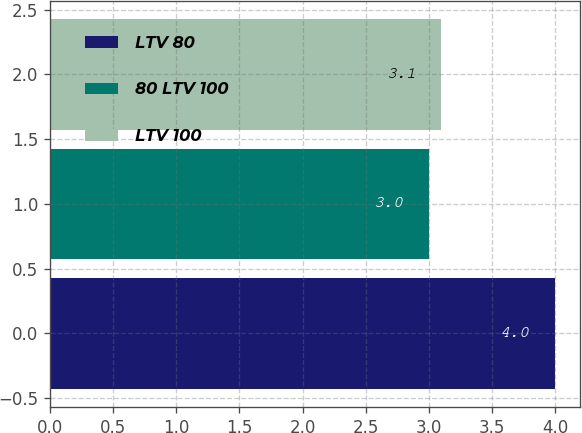<chart> <loc_0><loc_0><loc_500><loc_500><bar_chart><fcel>LTV 80<fcel>80 LTV 100<fcel>LTV 100<nl><fcel>4<fcel>3<fcel>3.1<nl></chart> 